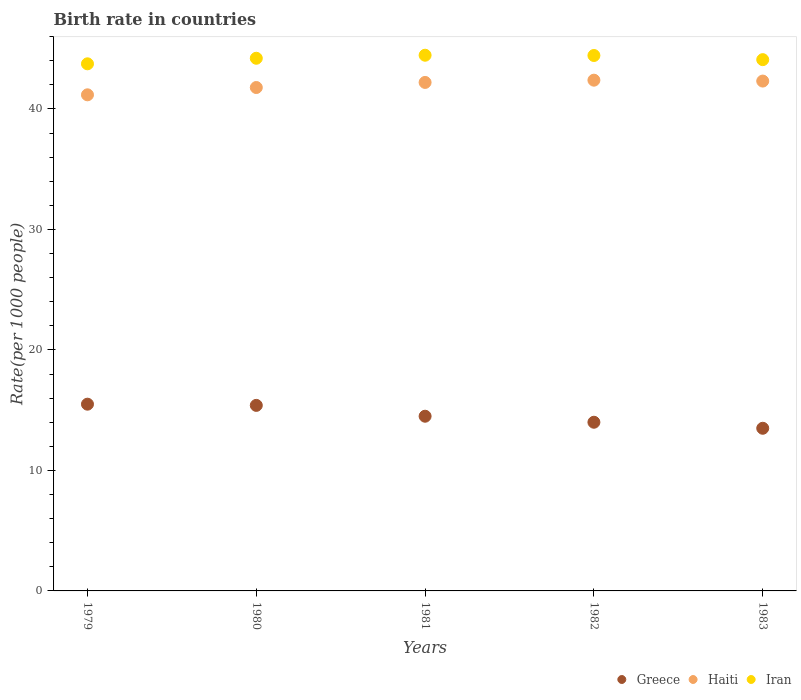How many different coloured dotlines are there?
Your answer should be compact. 3. Is the number of dotlines equal to the number of legend labels?
Provide a succinct answer. Yes. What is the birth rate in Iran in 1983?
Make the answer very short. 44.1. Across all years, what is the maximum birth rate in Iran?
Offer a terse response. 44.46. In which year was the birth rate in Greece maximum?
Your response must be concise. 1979. In which year was the birth rate in Haiti minimum?
Ensure brevity in your answer.  1979. What is the total birth rate in Haiti in the graph?
Give a very brief answer. 209.88. What is the difference between the birth rate in Haiti in 1980 and that in 1982?
Your answer should be very brief. -0.61. What is the difference between the birth rate in Iran in 1983 and the birth rate in Haiti in 1982?
Offer a very short reply. 1.7. What is the average birth rate in Iran per year?
Offer a very short reply. 44.19. In the year 1979, what is the difference between the birth rate in Haiti and birth rate in Iran?
Your response must be concise. -2.57. What is the ratio of the birth rate in Iran in 1980 to that in 1982?
Keep it short and to the point. 0.99. Is the difference between the birth rate in Haiti in 1980 and 1982 greater than the difference between the birth rate in Iran in 1980 and 1982?
Provide a succinct answer. No. What is the difference between the highest and the second highest birth rate in Haiti?
Your response must be concise. 0.07. Is the sum of the birth rate in Haiti in 1981 and 1983 greater than the maximum birth rate in Greece across all years?
Your answer should be compact. Yes. Is the birth rate in Haiti strictly less than the birth rate in Iran over the years?
Your answer should be compact. Yes. How many years are there in the graph?
Keep it short and to the point. 5. What is the difference between two consecutive major ticks on the Y-axis?
Your response must be concise. 10. Are the values on the major ticks of Y-axis written in scientific E-notation?
Make the answer very short. No. Does the graph contain grids?
Make the answer very short. No. How are the legend labels stacked?
Provide a succinct answer. Horizontal. What is the title of the graph?
Keep it short and to the point. Birth rate in countries. Does "United States" appear as one of the legend labels in the graph?
Make the answer very short. No. What is the label or title of the X-axis?
Your response must be concise. Years. What is the label or title of the Y-axis?
Offer a terse response. Rate(per 1000 people). What is the Rate(per 1000 people) in Haiti in 1979?
Offer a very short reply. 41.18. What is the Rate(per 1000 people) in Iran in 1979?
Offer a terse response. 43.75. What is the Rate(per 1000 people) of Greece in 1980?
Give a very brief answer. 15.4. What is the Rate(per 1000 people) of Haiti in 1980?
Offer a very short reply. 41.78. What is the Rate(per 1000 people) of Iran in 1980?
Provide a short and direct response. 44.21. What is the Rate(per 1000 people) in Greece in 1981?
Keep it short and to the point. 14.5. What is the Rate(per 1000 people) of Haiti in 1981?
Give a very brief answer. 42.2. What is the Rate(per 1000 people) in Iran in 1981?
Your answer should be very brief. 44.46. What is the Rate(per 1000 people) of Haiti in 1982?
Keep it short and to the point. 42.39. What is the Rate(per 1000 people) in Iran in 1982?
Make the answer very short. 44.44. What is the Rate(per 1000 people) in Greece in 1983?
Keep it short and to the point. 13.5. What is the Rate(per 1000 people) in Haiti in 1983?
Provide a succinct answer. 42.32. What is the Rate(per 1000 people) of Iran in 1983?
Provide a succinct answer. 44.1. Across all years, what is the maximum Rate(per 1000 people) of Haiti?
Provide a short and direct response. 42.39. Across all years, what is the maximum Rate(per 1000 people) in Iran?
Your answer should be compact. 44.46. Across all years, what is the minimum Rate(per 1000 people) in Greece?
Provide a succinct answer. 13.5. Across all years, what is the minimum Rate(per 1000 people) in Haiti?
Offer a terse response. 41.18. Across all years, what is the minimum Rate(per 1000 people) of Iran?
Keep it short and to the point. 43.75. What is the total Rate(per 1000 people) in Greece in the graph?
Your answer should be compact. 72.9. What is the total Rate(per 1000 people) of Haiti in the graph?
Your answer should be compact. 209.88. What is the total Rate(per 1000 people) of Iran in the graph?
Your response must be concise. 220.96. What is the difference between the Rate(per 1000 people) of Haiti in 1979 and that in 1980?
Keep it short and to the point. -0.61. What is the difference between the Rate(per 1000 people) of Iran in 1979 and that in 1980?
Your response must be concise. -0.46. What is the difference between the Rate(per 1000 people) of Haiti in 1979 and that in 1981?
Keep it short and to the point. -1.03. What is the difference between the Rate(per 1000 people) of Iran in 1979 and that in 1981?
Your response must be concise. -0.71. What is the difference between the Rate(per 1000 people) in Haiti in 1979 and that in 1982?
Offer a very short reply. -1.22. What is the difference between the Rate(per 1000 people) in Iran in 1979 and that in 1982?
Provide a succinct answer. -0.69. What is the difference between the Rate(per 1000 people) in Greece in 1979 and that in 1983?
Provide a short and direct response. 2. What is the difference between the Rate(per 1000 people) in Haiti in 1979 and that in 1983?
Provide a short and direct response. -1.14. What is the difference between the Rate(per 1000 people) of Iran in 1979 and that in 1983?
Your answer should be compact. -0.35. What is the difference between the Rate(per 1000 people) in Greece in 1980 and that in 1981?
Provide a succinct answer. 0.9. What is the difference between the Rate(per 1000 people) in Haiti in 1980 and that in 1981?
Make the answer very short. -0.42. What is the difference between the Rate(per 1000 people) of Iran in 1980 and that in 1981?
Your answer should be compact. -0.25. What is the difference between the Rate(per 1000 people) of Greece in 1980 and that in 1982?
Your answer should be compact. 1.4. What is the difference between the Rate(per 1000 people) of Haiti in 1980 and that in 1982?
Offer a very short reply. -0.61. What is the difference between the Rate(per 1000 people) of Iran in 1980 and that in 1982?
Offer a very short reply. -0.23. What is the difference between the Rate(per 1000 people) of Haiti in 1980 and that in 1983?
Your answer should be very brief. -0.54. What is the difference between the Rate(per 1000 people) of Iran in 1980 and that in 1983?
Your answer should be compact. 0.12. What is the difference between the Rate(per 1000 people) in Haiti in 1981 and that in 1982?
Make the answer very short. -0.19. What is the difference between the Rate(per 1000 people) of Iran in 1981 and that in 1982?
Provide a short and direct response. 0.02. What is the difference between the Rate(per 1000 people) in Greece in 1981 and that in 1983?
Your answer should be very brief. 1. What is the difference between the Rate(per 1000 people) in Haiti in 1981 and that in 1983?
Provide a succinct answer. -0.11. What is the difference between the Rate(per 1000 people) of Iran in 1981 and that in 1983?
Offer a terse response. 0.37. What is the difference between the Rate(per 1000 people) of Haiti in 1982 and that in 1983?
Give a very brief answer. 0.07. What is the difference between the Rate(per 1000 people) of Iran in 1982 and that in 1983?
Offer a terse response. 0.34. What is the difference between the Rate(per 1000 people) in Greece in 1979 and the Rate(per 1000 people) in Haiti in 1980?
Ensure brevity in your answer.  -26.28. What is the difference between the Rate(per 1000 people) of Greece in 1979 and the Rate(per 1000 people) of Iran in 1980?
Provide a succinct answer. -28.71. What is the difference between the Rate(per 1000 people) of Haiti in 1979 and the Rate(per 1000 people) of Iran in 1980?
Offer a terse response. -3.03. What is the difference between the Rate(per 1000 people) in Greece in 1979 and the Rate(per 1000 people) in Haiti in 1981?
Make the answer very short. -26.7. What is the difference between the Rate(per 1000 people) of Greece in 1979 and the Rate(per 1000 people) of Iran in 1981?
Your answer should be compact. -28.96. What is the difference between the Rate(per 1000 people) of Haiti in 1979 and the Rate(per 1000 people) of Iran in 1981?
Give a very brief answer. -3.29. What is the difference between the Rate(per 1000 people) in Greece in 1979 and the Rate(per 1000 people) in Haiti in 1982?
Keep it short and to the point. -26.89. What is the difference between the Rate(per 1000 people) of Greece in 1979 and the Rate(per 1000 people) of Iran in 1982?
Provide a succinct answer. -28.94. What is the difference between the Rate(per 1000 people) in Haiti in 1979 and the Rate(per 1000 people) in Iran in 1982?
Your response must be concise. -3.26. What is the difference between the Rate(per 1000 people) of Greece in 1979 and the Rate(per 1000 people) of Haiti in 1983?
Offer a very short reply. -26.82. What is the difference between the Rate(per 1000 people) in Greece in 1979 and the Rate(per 1000 people) in Iran in 1983?
Offer a terse response. -28.6. What is the difference between the Rate(per 1000 people) in Haiti in 1979 and the Rate(per 1000 people) in Iran in 1983?
Offer a very short reply. -2.92. What is the difference between the Rate(per 1000 people) in Greece in 1980 and the Rate(per 1000 people) in Haiti in 1981?
Make the answer very short. -26.8. What is the difference between the Rate(per 1000 people) of Greece in 1980 and the Rate(per 1000 people) of Iran in 1981?
Your response must be concise. -29.06. What is the difference between the Rate(per 1000 people) in Haiti in 1980 and the Rate(per 1000 people) in Iran in 1981?
Give a very brief answer. -2.68. What is the difference between the Rate(per 1000 people) in Greece in 1980 and the Rate(per 1000 people) in Haiti in 1982?
Make the answer very short. -26.99. What is the difference between the Rate(per 1000 people) in Greece in 1980 and the Rate(per 1000 people) in Iran in 1982?
Give a very brief answer. -29.04. What is the difference between the Rate(per 1000 people) of Haiti in 1980 and the Rate(per 1000 people) of Iran in 1982?
Offer a very short reply. -2.66. What is the difference between the Rate(per 1000 people) in Greece in 1980 and the Rate(per 1000 people) in Haiti in 1983?
Offer a terse response. -26.92. What is the difference between the Rate(per 1000 people) in Greece in 1980 and the Rate(per 1000 people) in Iran in 1983?
Provide a short and direct response. -28.7. What is the difference between the Rate(per 1000 people) in Haiti in 1980 and the Rate(per 1000 people) in Iran in 1983?
Offer a very short reply. -2.31. What is the difference between the Rate(per 1000 people) of Greece in 1981 and the Rate(per 1000 people) of Haiti in 1982?
Your answer should be very brief. -27.89. What is the difference between the Rate(per 1000 people) of Greece in 1981 and the Rate(per 1000 people) of Iran in 1982?
Give a very brief answer. -29.94. What is the difference between the Rate(per 1000 people) of Haiti in 1981 and the Rate(per 1000 people) of Iran in 1982?
Offer a terse response. -2.24. What is the difference between the Rate(per 1000 people) in Greece in 1981 and the Rate(per 1000 people) in Haiti in 1983?
Your answer should be very brief. -27.82. What is the difference between the Rate(per 1000 people) of Greece in 1981 and the Rate(per 1000 people) of Iran in 1983?
Ensure brevity in your answer.  -29.6. What is the difference between the Rate(per 1000 people) of Haiti in 1981 and the Rate(per 1000 people) of Iran in 1983?
Give a very brief answer. -1.89. What is the difference between the Rate(per 1000 people) of Greece in 1982 and the Rate(per 1000 people) of Haiti in 1983?
Provide a short and direct response. -28.32. What is the difference between the Rate(per 1000 people) in Greece in 1982 and the Rate(per 1000 people) in Iran in 1983?
Give a very brief answer. -30.1. What is the difference between the Rate(per 1000 people) of Haiti in 1982 and the Rate(per 1000 people) of Iran in 1983?
Your response must be concise. -1.7. What is the average Rate(per 1000 people) in Greece per year?
Give a very brief answer. 14.58. What is the average Rate(per 1000 people) of Haiti per year?
Keep it short and to the point. 41.98. What is the average Rate(per 1000 people) of Iran per year?
Your answer should be compact. 44.19. In the year 1979, what is the difference between the Rate(per 1000 people) of Greece and Rate(per 1000 people) of Haiti?
Make the answer very short. -25.68. In the year 1979, what is the difference between the Rate(per 1000 people) in Greece and Rate(per 1000 people) in Iran?
Offer a terse response. -28.25. In the year 1979, what is the difference between the Rate(per 1000 people) of Haiti and Rate(per 1000 people) of Iran?
Your answer should be compact. -2.57. In the year 1980, what is the difference between the Rate(per 1000 people) in Greece and Rate(per 1000 people) in Haiti?
Give a very brief answer. -26.38. In the year 1980, what is the difference between the Rate(per 1000 people) of Greece and Rate(per 1000 people) of Iran?
Offer a very short reply. -28.81. In the year 1980, what is the difference between the Rate(per 1000 people) of Haiti and Rate(per 1000 people) of Iran?
Provide a succinct answer. -2.43. In the year 1981, what is the difference between the Rate(per 1000 people) of Greece and Rate(per 1000 people) of Haiti?
Give a very brief answer. -27.7. In the year 1981, what is the difference between the Rate(per 1000 people) of Greece and Rate(per 1000 people) of Iran?
Your response must be concise. -29.96. In the year 1981, what is the difference between the Rate(per 1000 people) of Haiti and Rate(per 1000 people) of Iran?
Offer a very short reply. -2.26. In the year 1982, what is the difference between the Rate(per 1000 people) of Greece and Rate(per 1000 people) of Haiti?
Your answer should be very brief. -28.39. In the year 1982, what is the difference between the Rate(per 1000 people) in Greece and Rate(per 1000 people) in Iran?
Your answer should be compact. -30.44. In the year 1982, what is the difference between the Rate(per 1000 people) in Haiti and Rate(per 1000 people) in Iran?
Your response must be concise. -2.05. In the year 1983, what is the difference between the Rate(per 1000 people) in Greece and Rate(per 1000 people) in Haiti?
Offer a terse response. -28.82. In the year 1983, what is the difference between the Rate(per 1000 people) of Greece and Rate(per 1000 people) of Iran?
Your answer should be very brief. -30.6. In the year 1983, what is the difference between the Rate(per 1000 people) in Haiti and Rate(per 1000 people) in Iran?
Provide a short and direct response. -1.78. What is the ratio of the Rate(per 1000 people) of Greece in 1979 to that in 1980?
Provide a short and direct response. 1.01. What is the ratio of the Rate(per 1000 people) in Haiti in 1979 to that in 1980?
Your answer should be very brief. 0.99. What is the ratio of the Rate(per 1000 people) of Greece in 1979 to that in 1981?
Offer a terse response. 1.07. What is the ratio of the Rate(per 1000 people) of Haiti in 1979 to that in 1981?
Keep it short and to the point. 0.98. What is the ratio of the Rate(per 1000 people) of Iran in 1979 to that in 1981?
Offer a terse response. 0.98. What is the ratio of the Rate(per 1000 people) in Greece in 1979 to that in 1982?
Keep it short and to the point. 1.11. What is the ratio of the Rate(per 1000 people) of Haiti in 1979 to that in 1982?
Offer a very short reply. 0.97. What is the ratio of the Rate(per 1000 people) of Iran in 1979 to that in 1982?
Your answer should be compact. 0.98. What is the ratio of the Rate(per 1000 people) of Greece in 1979 to that in 1983?
Make the answer very short. 1.15. What is the ratio of the Rate(per 1000 people) of Haiti in 1979 to that in 1983?
Make the answer very short. 0.97. What is the ratio of the Rate(per 1000 people) of Iran in 1979 to that in 1983?
Your answer should be very brief. 0.99. What is the ratio of the Rate(per 1000 people) of Greece in 1980 to that in 1981?
Your answer should be very brief. 1.06. What is the ratio of the Rate(per 1000 people) in Haiti in 1980 to that in 1981?
Keep it short and to the point. 0.99. What is the ratio of the Rate(per 1000 people) in Haiti in 1980 to that in 1982?
Your answer should be compact. 0.99. What is the ratio of the Rate(per 1000 people) in Iran in 1980 to that in 1982?
Offer a very short reply. 0.99. What is the ratio of the Rate(per 1000 people) in Greece in 1980 to that in 1983?
Keep it short and to the point. 1.14. What is the ratio of the Rate(per 1000 people) in Haiti in 1980 to that in 1983?
Make the answer very short. 0.99. What is the ratio of the Rate(per 1000 people) of Iran in 1980 to that in 1983?
Your answer should be very brief. 1. What is the ratio of the Rate(per 1000 people) in Greece in 1981 to that in 1982?
Your answer should be very brief. 1.04. What is the ratio of the Rate(per 1000 people) of Greece in 1981 to that in 1983?
Make the answer very short. 1.07. What is the ratio of the Rate(per 1000 people) in Iran in 1981 to that in 1983?
Provide a succinct answer. 1.01. What is the ratio of the Rate(per 1000 people) in Greece in 1982 to that in 1983?
Provide a succinct answer. 1.04. What is the ratio of the Rate(per 1000 people) of Haiti in 1982 to that in 1983?
Your answer should be compact. 1. What is the difference between the highest and the second highest Rate(per 1000 people) of Greece?
Provide a short and direct response. 0.1. What is the difference between the highest and the second highest Rate(per 1000 people) in Haiti?
Ensure brevity in your answer.  0.07. What is the difference between the highest and the second highest Rate(per 1000 people) of Iran?
Give a very brief answer. 0.02. What is the difference between the highest and the lowest Rate(per 1000 people) in Greece?
Ensure brevity in your answer.  2. What is the difference between the highest and the lowest Rate(per 1000 people) in Haiti?
Give a very brief answer. 1.22. What is the difference between the highest and the lowest Rate(per 1000 people) in Iran?
Your answer should be compact. 0.71. 